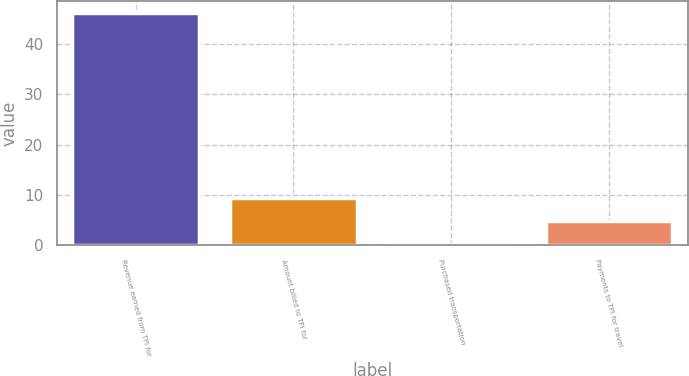Convert chart to OTSL. <chart><loc_0><loc_0><loc_500><loc_500><bar_chart><fcel>Revenue earned from TPI for<fcel>Amount billed to TPI for<fcel>Purchased transportation<fcel>Payments to TPI for travel<nl><fcel>46.2<fcel>9.4<fcel>0.2<fcel>4.8<nl></chart> 